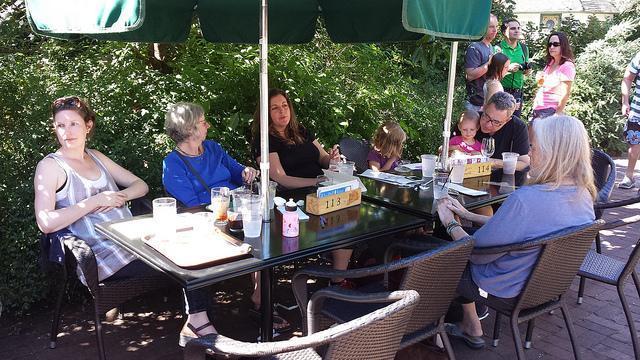How many children are in this picture?
Give a very brief answer. 3. How many people are visible?
Give a very brief answer. 6. How many chairs are there?
Give a very brief answer. 5. How many dining tables are in the photo?
Give a very brief answer. 2. How many dogs are there?
Give a very brief answer. 0. 